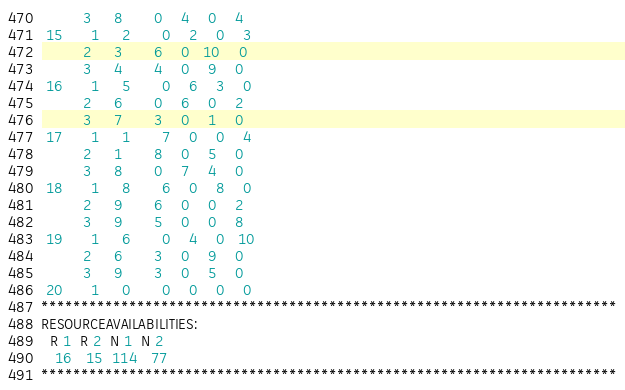<code> <loc_0><loc_0><loc_500><loc_500><_ObjectiveC_>         3     8       0    4    0    4
 15      1     2       0    2    0    3
         2     3       6    0   10    0
         3     4       4    0    9    0
 16      1     5       0    6    3    0
         2     6       0    6    0    2
         3     7       3    0    1    0
 17      1     1       7    0    0    4
         2     1       8    0    5    0
         3     8       0    7    4    0
 18      1     8       6    0    8    0
         2     9       6    0    0    2
         3     9       5    0    0    8
 19      1     6       0    4    0   10
         2     6       3    0    9    0
         3     9       3    0    5    0
 20      1     0       0    0    0    0
************************************************************************
RESOURCEAVAILABILITIES:
  R 1  R 2  N 1  N 2
   16   15  114   77
************************************************************************
</code> 